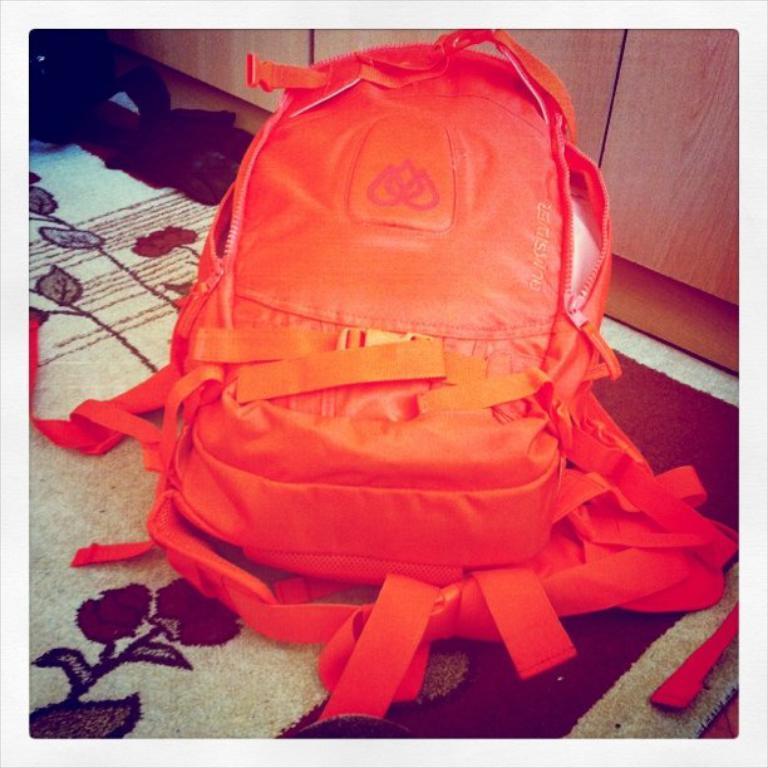Can you describe this image briefly? In this picture we can see a backpack. 